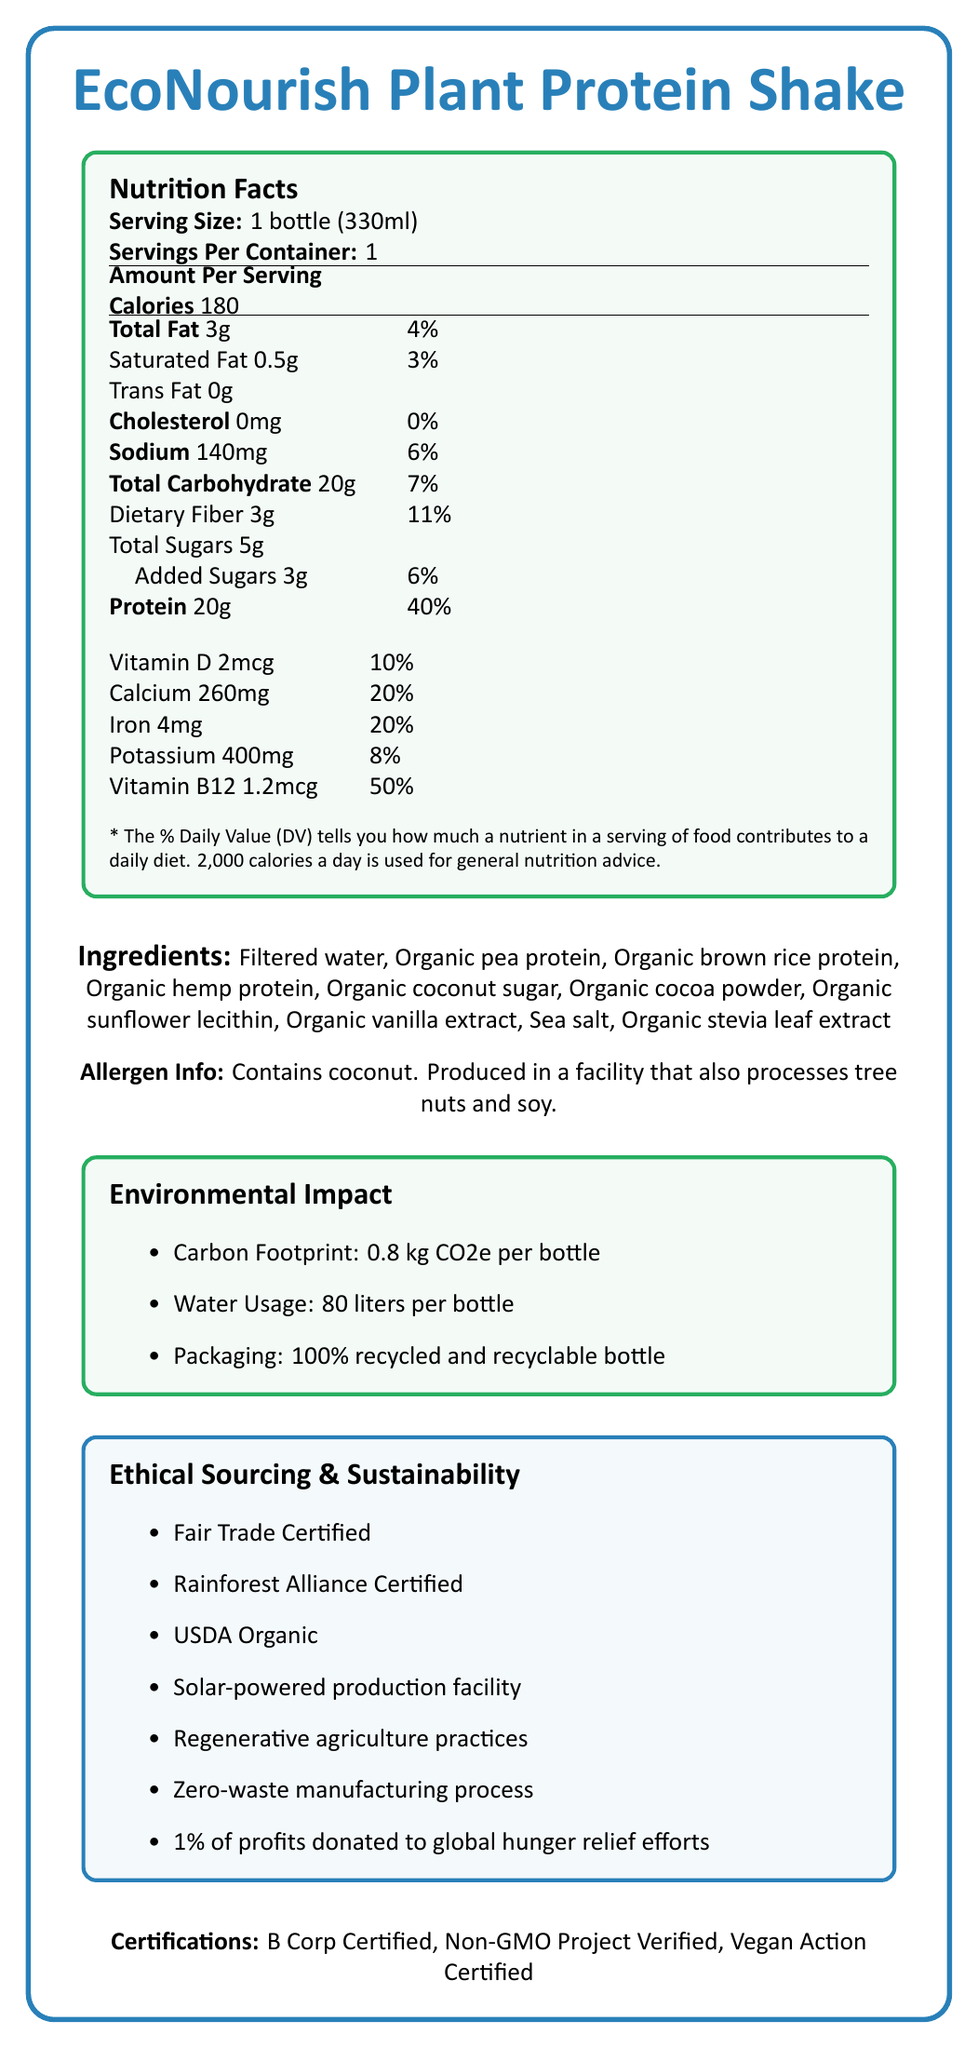what is the serving size of the EcoNourish Plant Protein Shake? The serving size is listed as "1 bottle (330ml)" in the Nutrition Facts section.
Answer: 1 bottle (330ml) how many grams of protein are in one serving? The protein content per serving is shown as "20g" in the Nutrition Facts section.
Answer: 20g how much added sugar is in the shake? The amount of added sugar in the shake is listed as "3g" under the "Total Sugars" section in the Nutrition Facts.
Answer: 3g how much calcium does one serving provide? The Nutrition Facts section shows that each serving provides "260mg" of calcium.
Answer: 260mg how many calories are in one serving? The Nutrition Facts section lists the calories per serving as "180".
Answer: 180 What is the daily value percentage of Vitamin B12 provided by the shake? The daily value percentage for Vitamin B12 is given as "50%" in the Nutrition Facts.
Answer: 50% Does the product contain any cholesterol? The Cholesterol amount is listed as "0mg," indicating no cholesterol content.
Answer: No Which environmental impact metric is not listed? A. Carbon Footprint B. Water Usage C. Energy Usage D. Packaging The document lists the carbon footprint, water usage, and packaging but does not mention energy usage.
Answer: C. Energy Usage Which of the following certifications does the EcoNourish Plant Protein Shake have? A. Fair Trade Certified B. USDA Organic C. Gluten-Free D. Non-GMO Project Verified The certifications listed include Fair Trade Certified, USDA Organic, and Non-GMO Project Verified, but not Gluten-Free.
Answer: C. Gluten-Free Is the EcoNourish Plant Protein Shake suitable for vegans? The product is "Vegan Action Certified" as mentioned in the certifications section.
Answer: Yes Summarize the key features of the EcoNourish Plant Protein Shake. The document provides nutritional information, ingredient details, allergen information, environmental impact metrics, ethical sourcing, sustainability initiatives, and certifications to highlight the product's health and sustainability profile.
Answer: The EcoNourish Plant Protein Shake is a plant-based protein shake with 20g of protein per serving and 180 calories. It is made from organic ingredients, is allergen-friendly, and has notable certifications like Fair Trade, USDA Organic, and Non-GMO Project Verified. The product emphasizes its environmental impact by having a low carbon footprint, sustainable water usage, and recyclable packaging. It also participates in sustainability initiatives such as solar-powered production and practices zero-waste manufacturing. What is the exact amount of carbon footprint associated with one bottle of the shake? The document states that the carbon footprint is "0.8 kg CO2e per bottle."
Answer: 0.8 kg CO2e What percentage of profits are donated to global hunger relief efforts? The document mentions that "1% of profits are donated to global hunger relief efforts."
Answer: 1% 